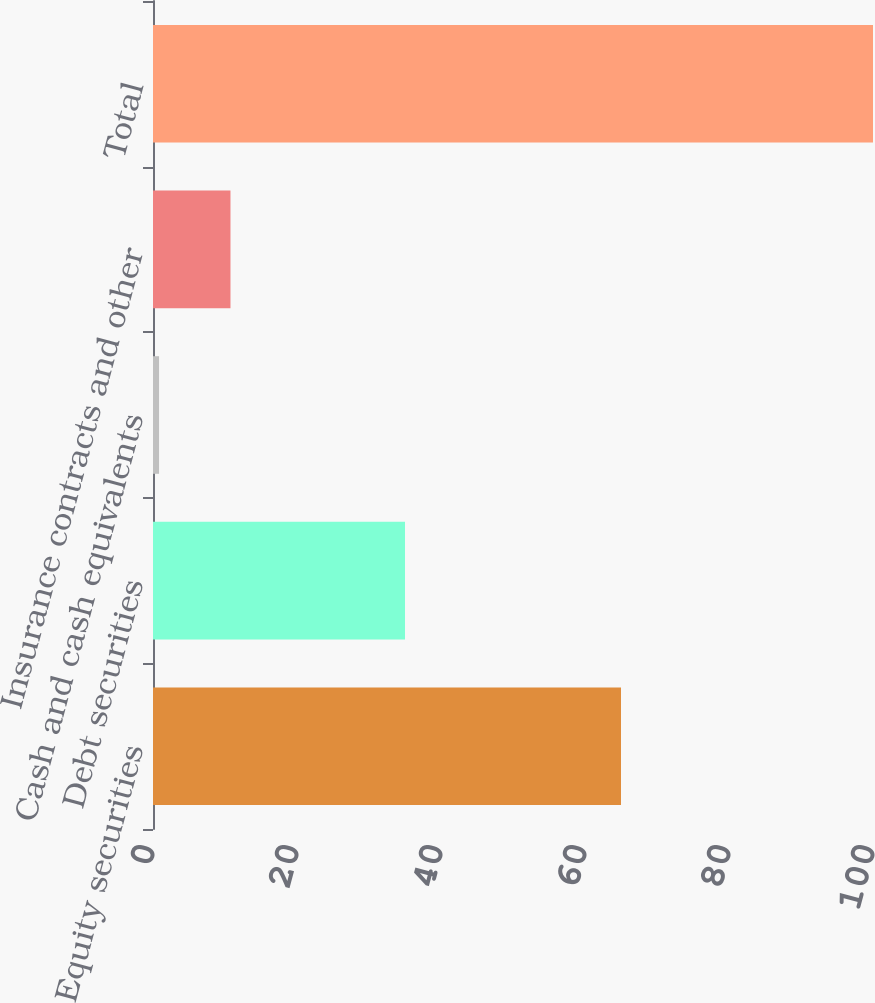Convert chart. <chart><loc_0><loc_0><loc_500><loc_500><bar_chart><fcel>Equity securities<fcel>Debt securities<fcel>Cash and cash equivalents<fcel>Insurance contracts and other<fcel>Total<nl><fcel>65<fcel>35<fcel>0.84<fcel>10.76<fcel>100<nl></chart> 